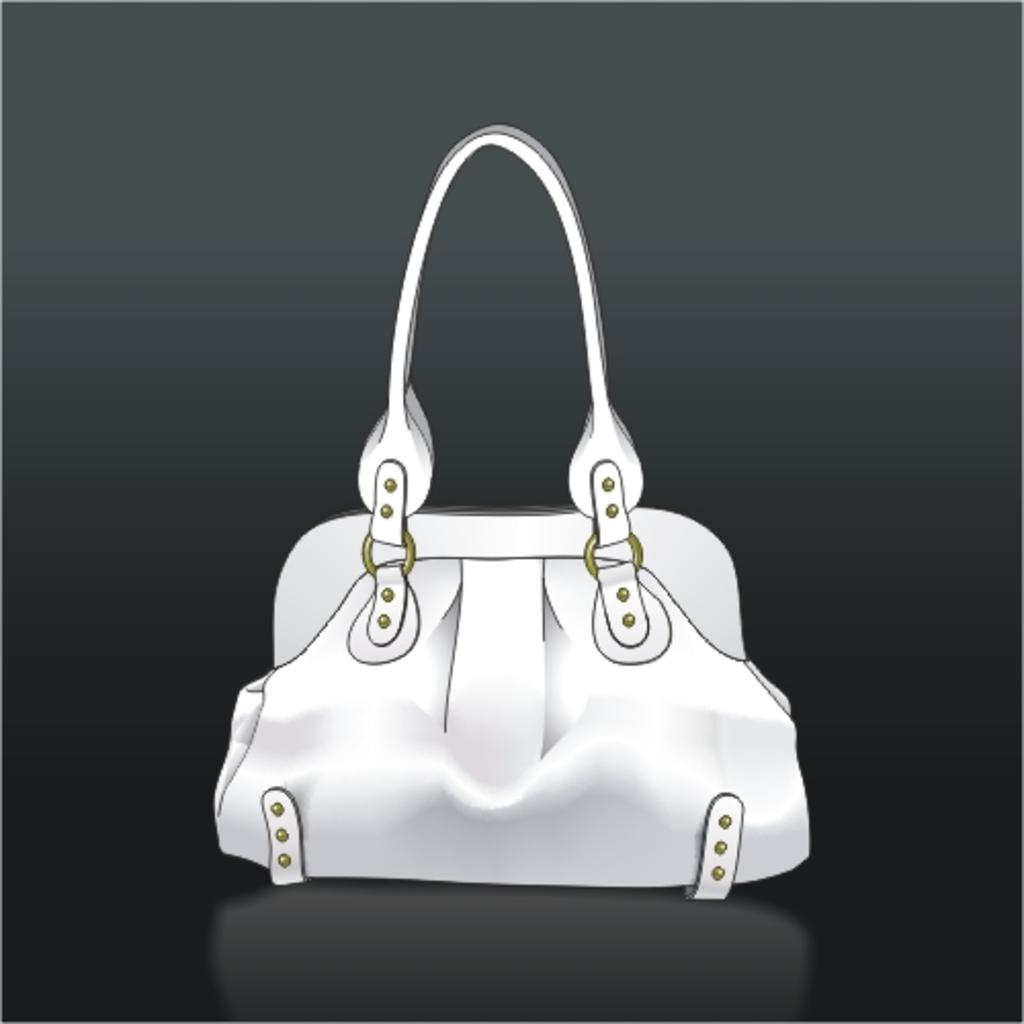What object is present in the image? There is a bag in the image. What is inside the bag? The bag has a belt in it. What type of curtain can be seen hanging from the moon in the image? There is no curtain or moon present in the image; it only features a bag with a belt inside. 